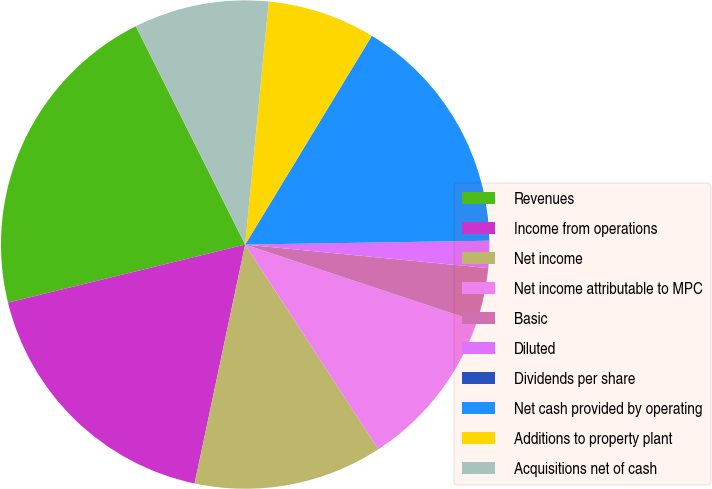Convert chart to OTSL. <chart><loc_0><loc_0><loc_500><loc_500><pie_chart><fcel>Revenues<fcel>Income from operations<fcel>Net income<fcel>Net income attributable to MPC<fcel>Basic<fcel>Diluted<fcel>Dividends per share<fcel>Net cash provided by operating<fcel>Additions to property plant<fcel>Acquisitions net of cash<nl><fcel>21.43%<fcel>17.86%<fcel>12.5%<fcel>10.71%<fcel>3.57%<fcel>1.79%<fcel>0.0%<fcel>16.07%<fcel>7.14%<fcel>8.93%<nl></chart> 